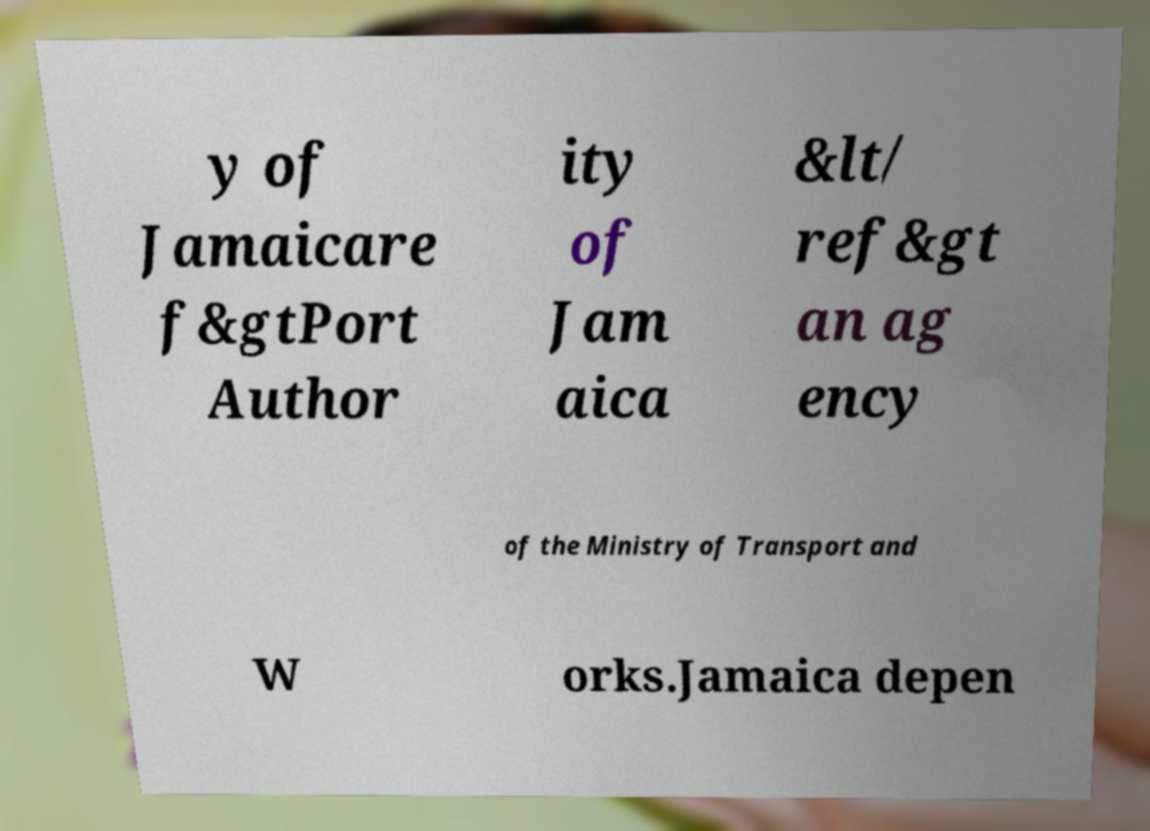Please identify and transcribe the text found in this image. y of Jamaicare f&gtPort Author ity of Jam aica &lt/ ref&gt an ag ency of the Ministry of Transport and W orks.Jamaica depen 